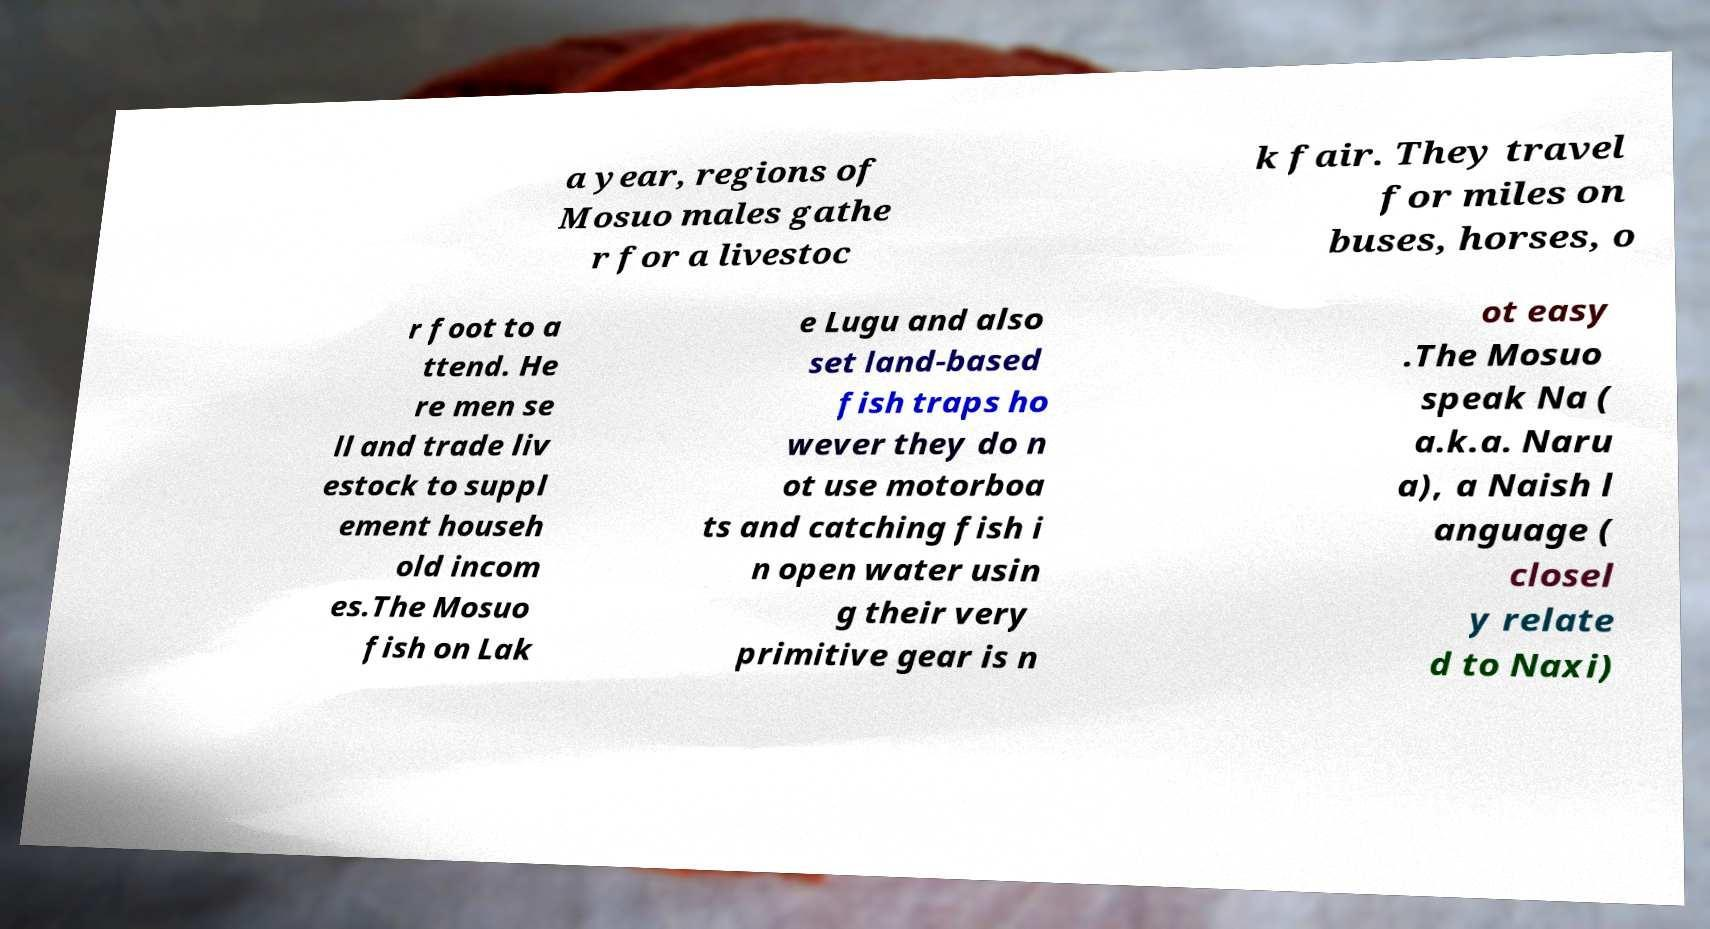Can you read and provide the text displayed in the image?This photo seems to have some interesting text. Can you extract and type it out for me? a year, regions of Mosuo males gathe r for a livestoc k fair. They travel for miles on buses, horses, o r foot to a ttend. He re men se ll and trade liv estock to suppl ement househ old incom es.The Mosuo fish on Lak e Lugu and also set land-based fish traps ho wever they do n ot use motorboa ts and catching fish i n open water usin g their very primitive gear is n ot easy .The Mosuo speak Na ( a.k.a. Naru a), a Naish l anguage ( closel y relate d to Naxi) 